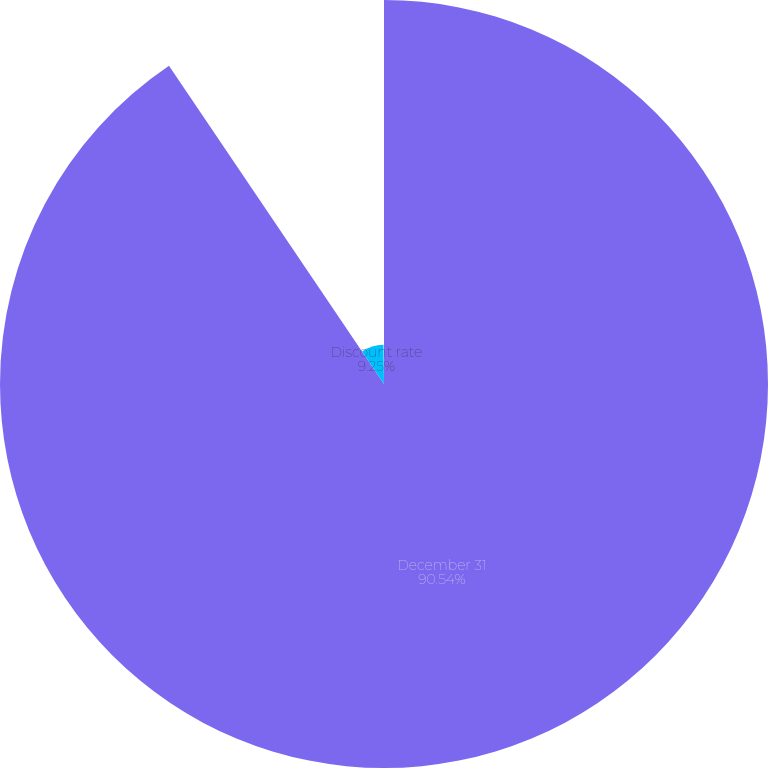Convert chart. <chart><loc_0><loc_0><loc_500><loc_500><pie_chart><fcel>December 31<fcel>Discount rate<fcel>Expected long-term rate of<nl><fcel>90.54%<fcel>9.25%<fcel>0.21%<nl></chart> 